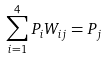<formula> <loc_0><loc_0><loc_500><loc_500>\sum _ { i = 1 } ^ { 4 } P _ { i } W _ { i j } = P _ { j }</formula> 